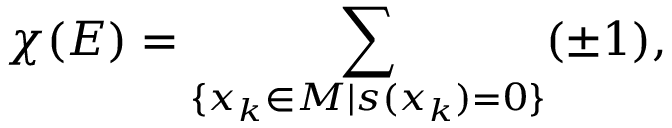<formula> <loc_0><loc_0><loc_500><loc_500>\chi ( E ) = \sum _ { \{ x _ { k } \in M | s ( x _ { k } ) = 0 \} } ( \pm 1 ) ,</formula> 